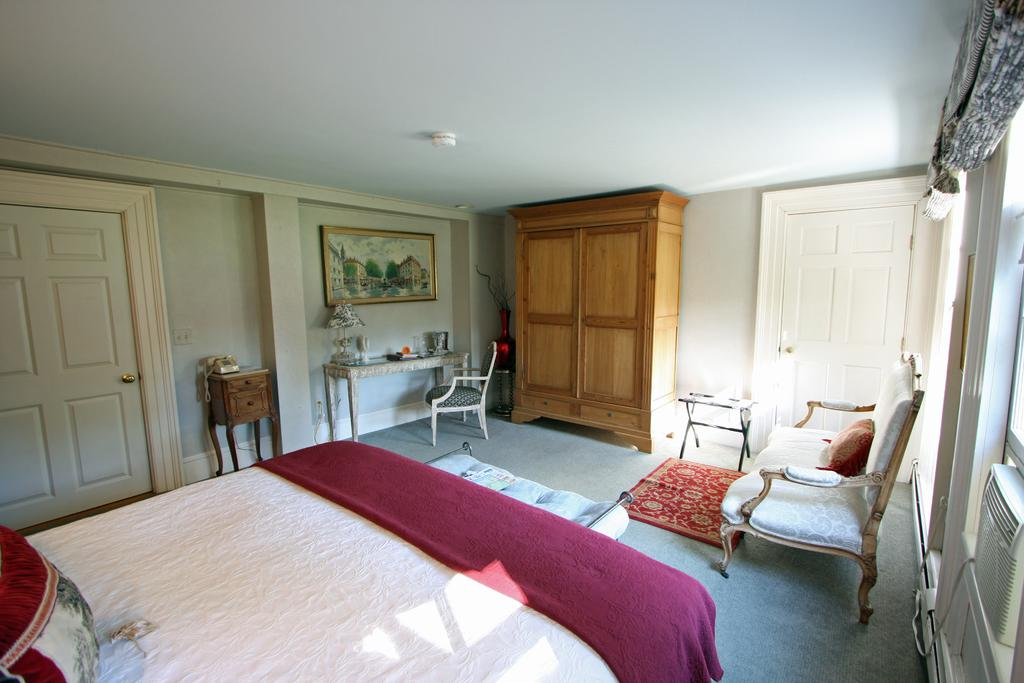What type of furniture is present in the image? There is a bed, chairs, tables, and a sofa in the image. What is on the bed in the image? The bed has a pillow and a blanket. What can be seen on the wall in the image? There is a photo on the wall in the image. Are there any doors visible in the image? Yes, there are doors in the image. Can you see any toothbrushes or quicksand in the image? No, there are no toothbrushes or quicksand present in the image. 